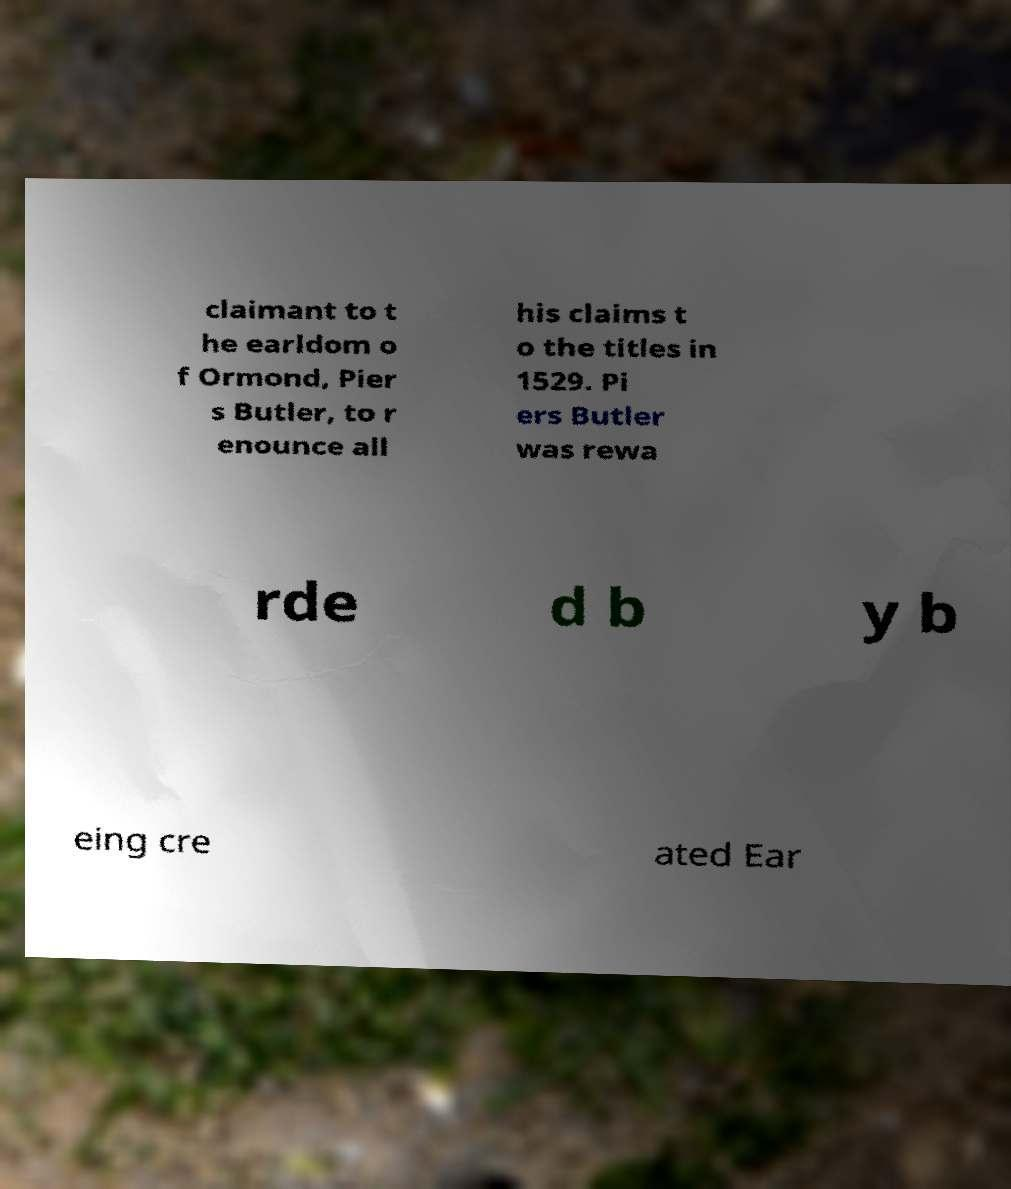Could you extract and type out the text from this image? claimant to t he earldom o f Ormond, Pier s Butler, to r enounce all his claims t o the titles in 1529. Pi ers Butler was rewa rde d b y b eing cre ated Ear 